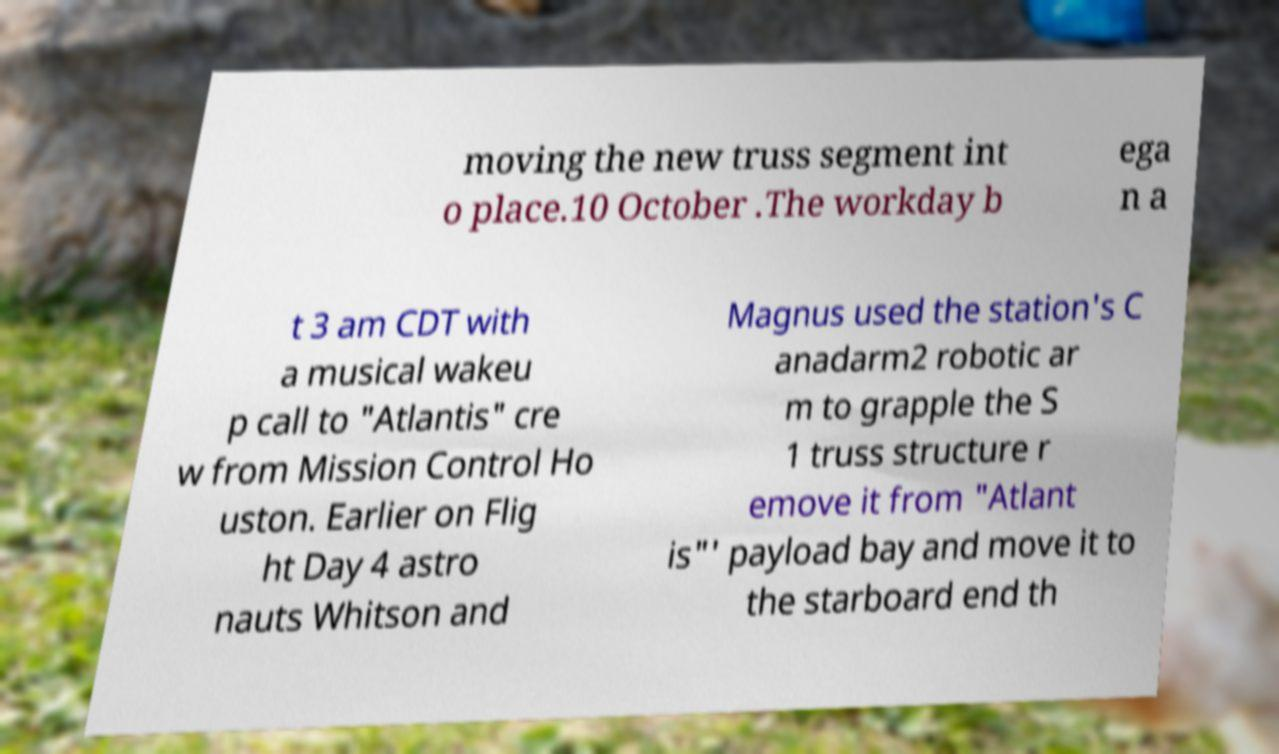Please read and relay the text visible in this image. What does it say? moving the new truss segment int o place.10 October .The workday b ega n a t 3 am CDT with a musical wakeu p call to "Atlantis" cre w from Mission Control Ho uston. Earlier on Flig ht Day 4 astro nauts Whitson and Magnus used the station's C anadarm2 robotic ar m to grapple the S 1 truss structure r emove it from "Atlant is"' payload bay and move it to the starboard end th 